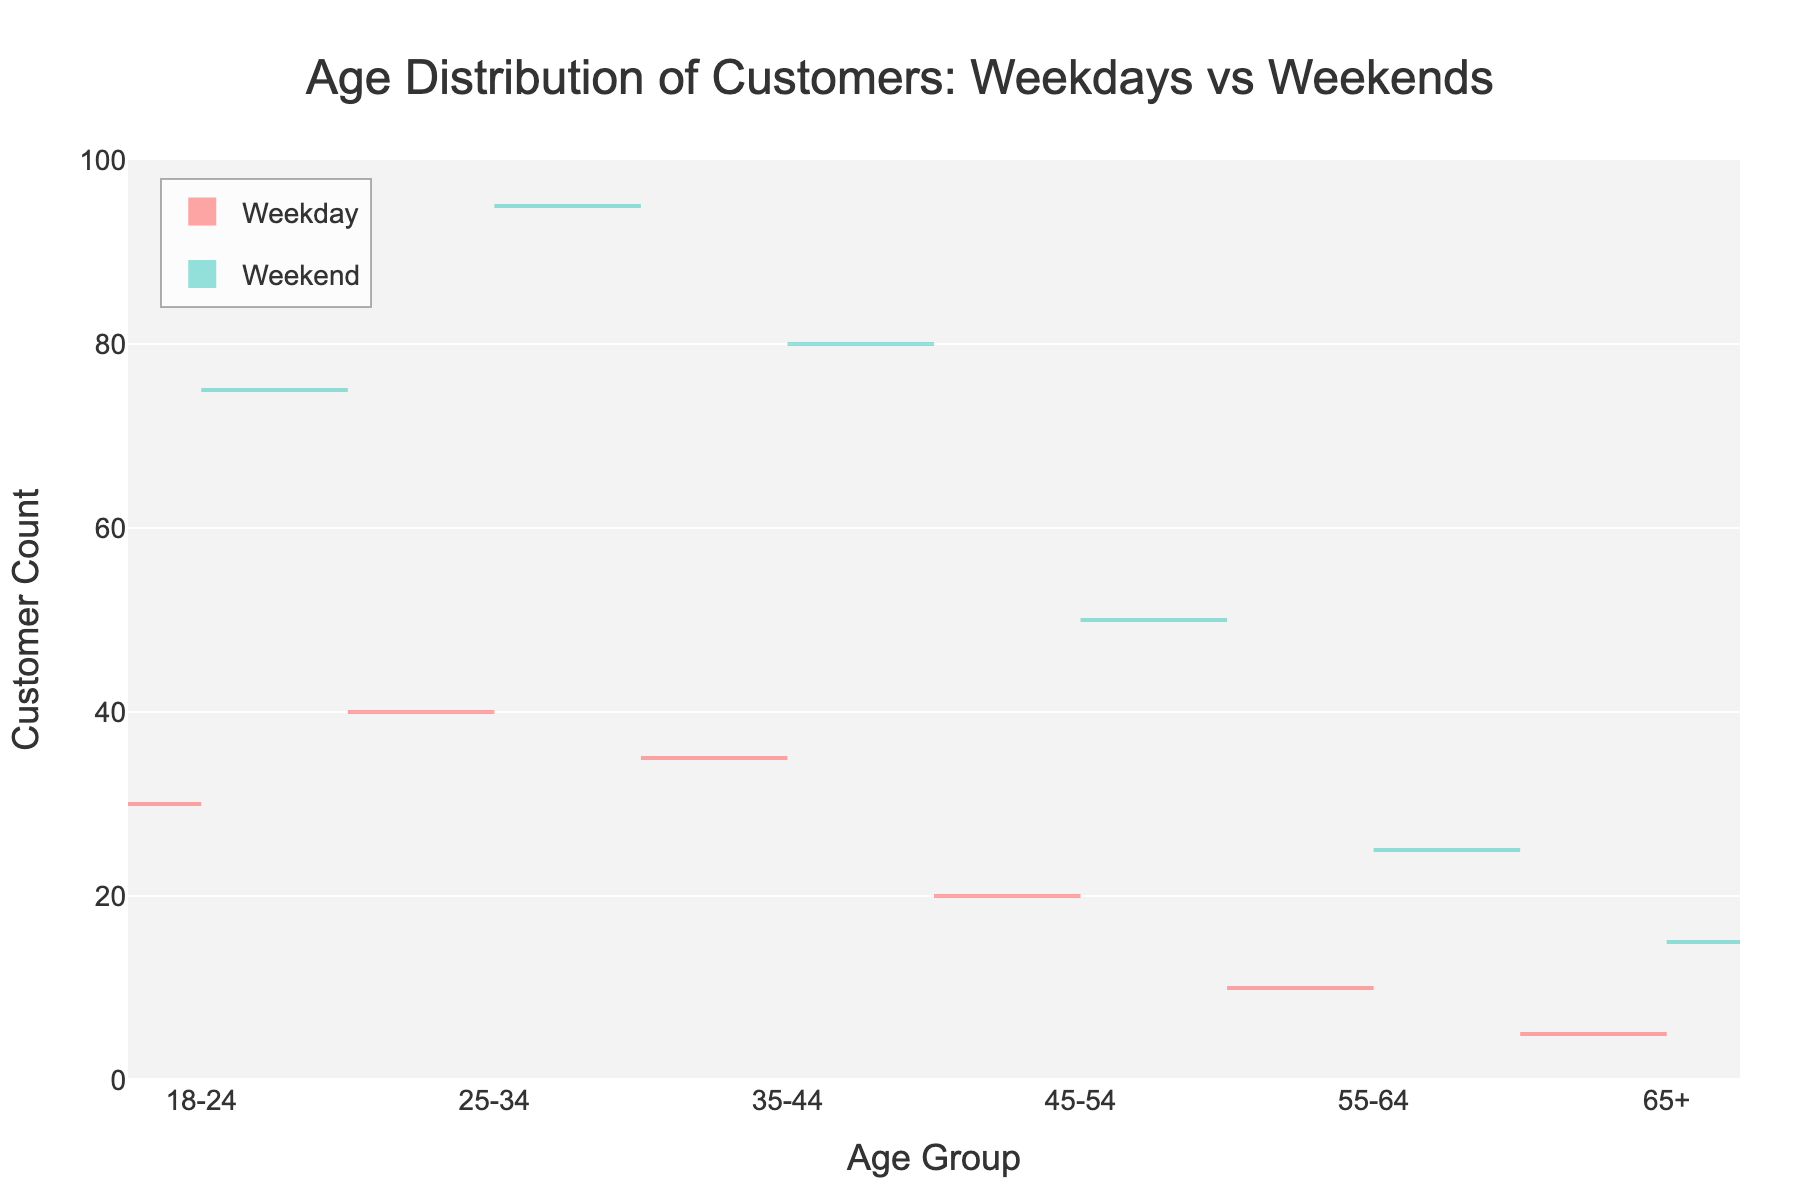What is the title of the plot? The title is located at the top center of the plot. It describes the content, making it easy to understand that the plot is about the age distribution of customers on different days.
Answer: Age Distribution of Customers: Weekdays vs Weekends Which color represents the weekday data? The plot uses two different colors to distinguish between weekdays and weekends. The weekday data is shown with a shade of red, as indicated by the negative side of the violin plot.
Answer: Red Which age group has the highest customer count on weekends? By observing the height of the plots on the positive side, the age group with the highest peak represents the highest customer count on weekends.
Answer: 25-34 How many age groups are represented in the plot? Each age group is labeled on the x-axis, and counting these labels reveals the number of groups shown.
Answer: 6 Compare the customer counts for the 35-44 age group on weekdays versus weekends. The height of the violin plot for the 35-44 age group can be compared on both the negative (weekdays) and positive (weekends) sides.
Answer: Weekends have higher counts What is the total customer count for the 45-54 age group on both weekdays and weekends? Summing up the counts from both weekdays (20) and weekends (50) for the 45-54 age group gives the total.
Answer: 70 Which age group sees the least amount of difference between weekends and weekdays in customer counts? By observing the relative difference in the heights of the plots on either side of the center for each age group, the age group with the smallest difference can be identified.
Answer: 65+ Which side of the plot has a larger spread, weekdays or weekends? The spread refers to the range of the violin plots, so by comparing the overall spread on either side of the plot, we can determine which day type has a larger spread.
Answer: Weekends What can you infer about the age distribution trend on weekends as compared to weekdays? By observing the general pattern of the violin plots, we can note how the customer distribution shifts between weekdays and weekends. It shows that more young and middle-aged people visit on weekends.
Answer: Weekends have more young and middle-aged customers 